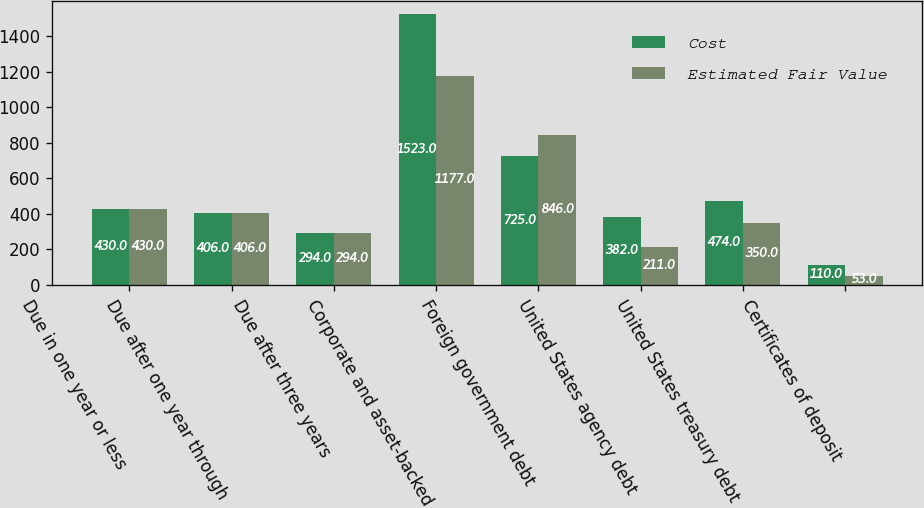Convert chart to OTSL. <chart><loc_0><loc_0><loc_500><loc_500><stacked_bar_chart><ecel><fcel>Due in one year or less<fcel>Due after one year through<fcel>Due after three years<fcel>Corporate and asset-backed<fcel>Foreign government debt<fcel>United States agency debt<fcel>United States treasury debt<fcel>Certificates of deposit<nl><fcel>Cost<fcel>430<fcel>406<fcel>294<fcel>1523<fcel>725<fcel>382<fcel>474<fcel>110<nl><fcel>Estimated Fair Value<fcel>430<fcel>406<fcel>294<fcel>1177<fcel>846<fcel>211<fcel>350<fcel>53<nl></chart> 